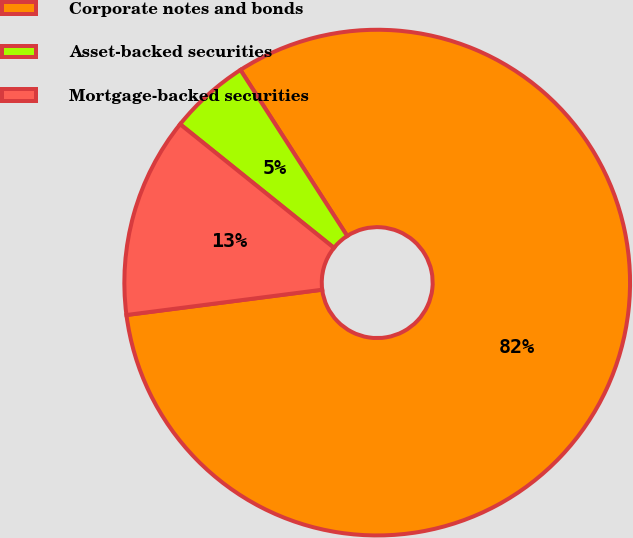<chart> <loc_0><loc_0><loc_500><loc_500><pie_chart><fcel>Corporate notes and bonds<fcel>Asset-backed securities<fcel>Mortgage-backed securities<nl><fcel>82.05%<fcel>5.13%<fcel>12.82%<nl></chart> 